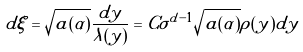<formula> <loc_0><loc_0><loc_500><loc_500>d \xi = \sqrt { a ( \alpha ) } \frac { d y } { \lambda ( y ) } = C \sigma ^ { d - 1 } \sqrt { a ( \alpha ) } \rho ( y ) d y</formula> 